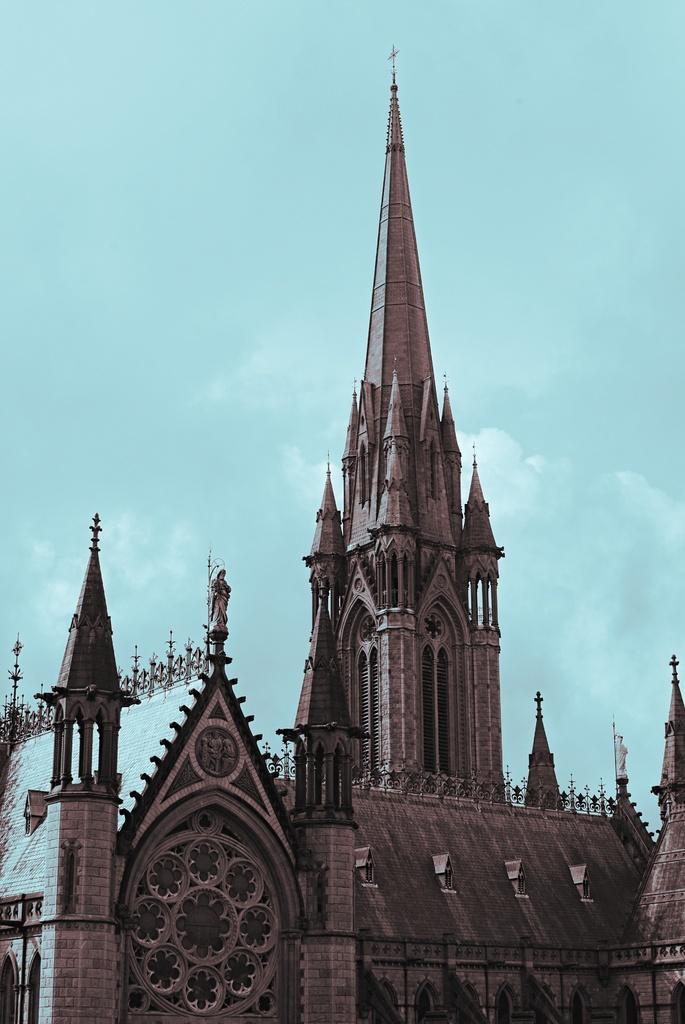Could you give a brief overview of what you see in this image? In this image we can see a building with windows and the sky which looks cloudy. 